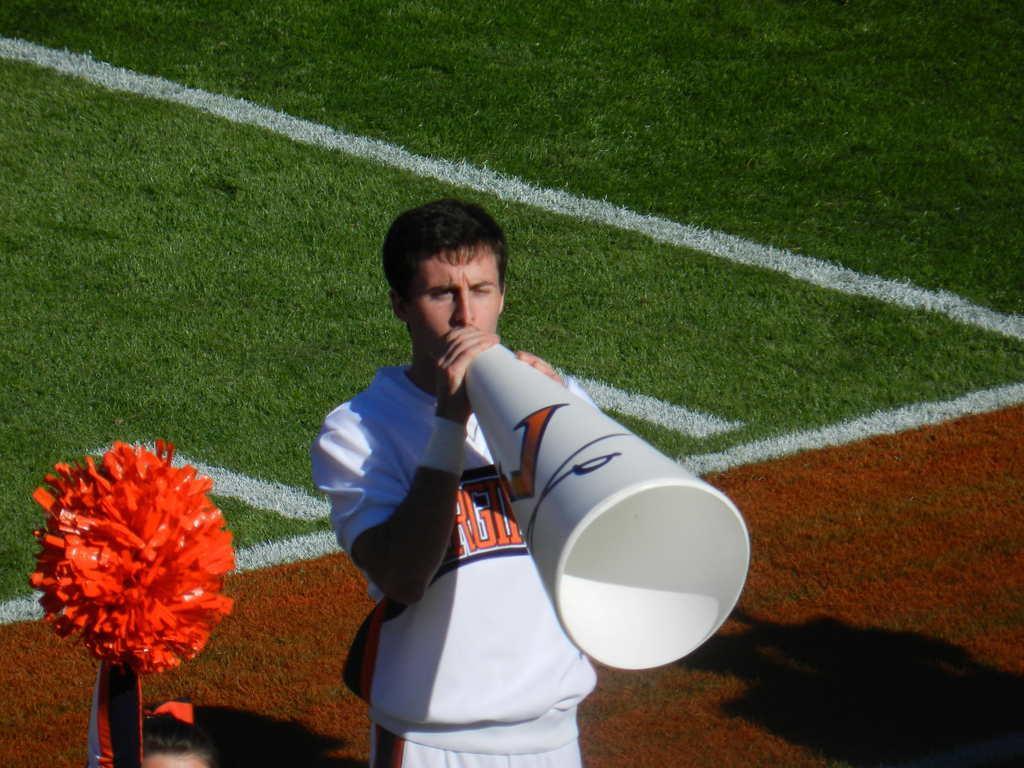Can you describe this image briefly? In this image we can see two persons standing on the ground. One woman is holding a pom pom in her hand. One person is holding a pipe in his hands. 